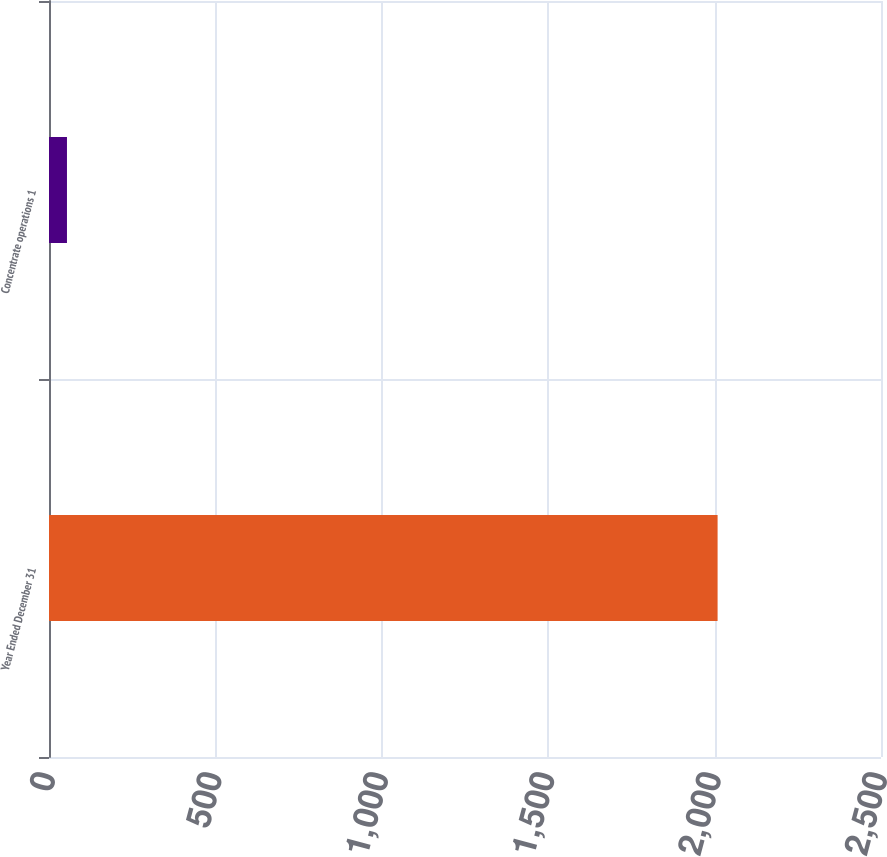Convert chart. <chart><loc_0><loc_0><loc_500><loc_500><bar_chart><fcel>Year Ended December 31<fcel>Concentrate operations 1<nl><fcel>2009<fcel>54<nl></chart> 